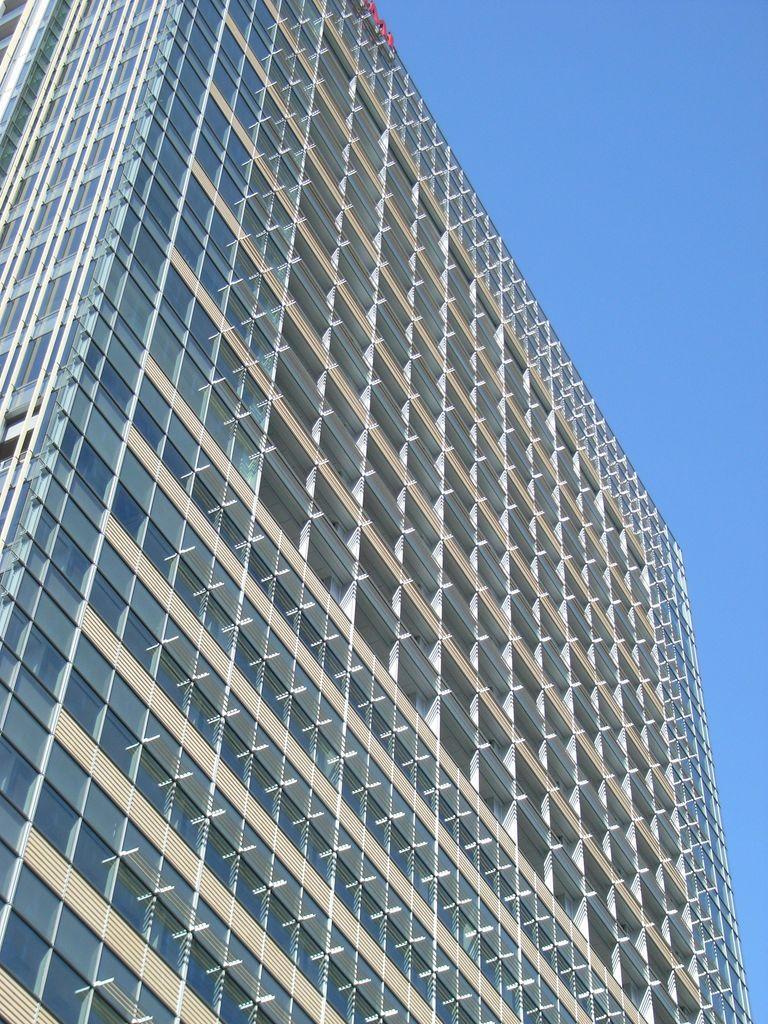Can you describe this image briefly? In this image there is a building and the sky. 